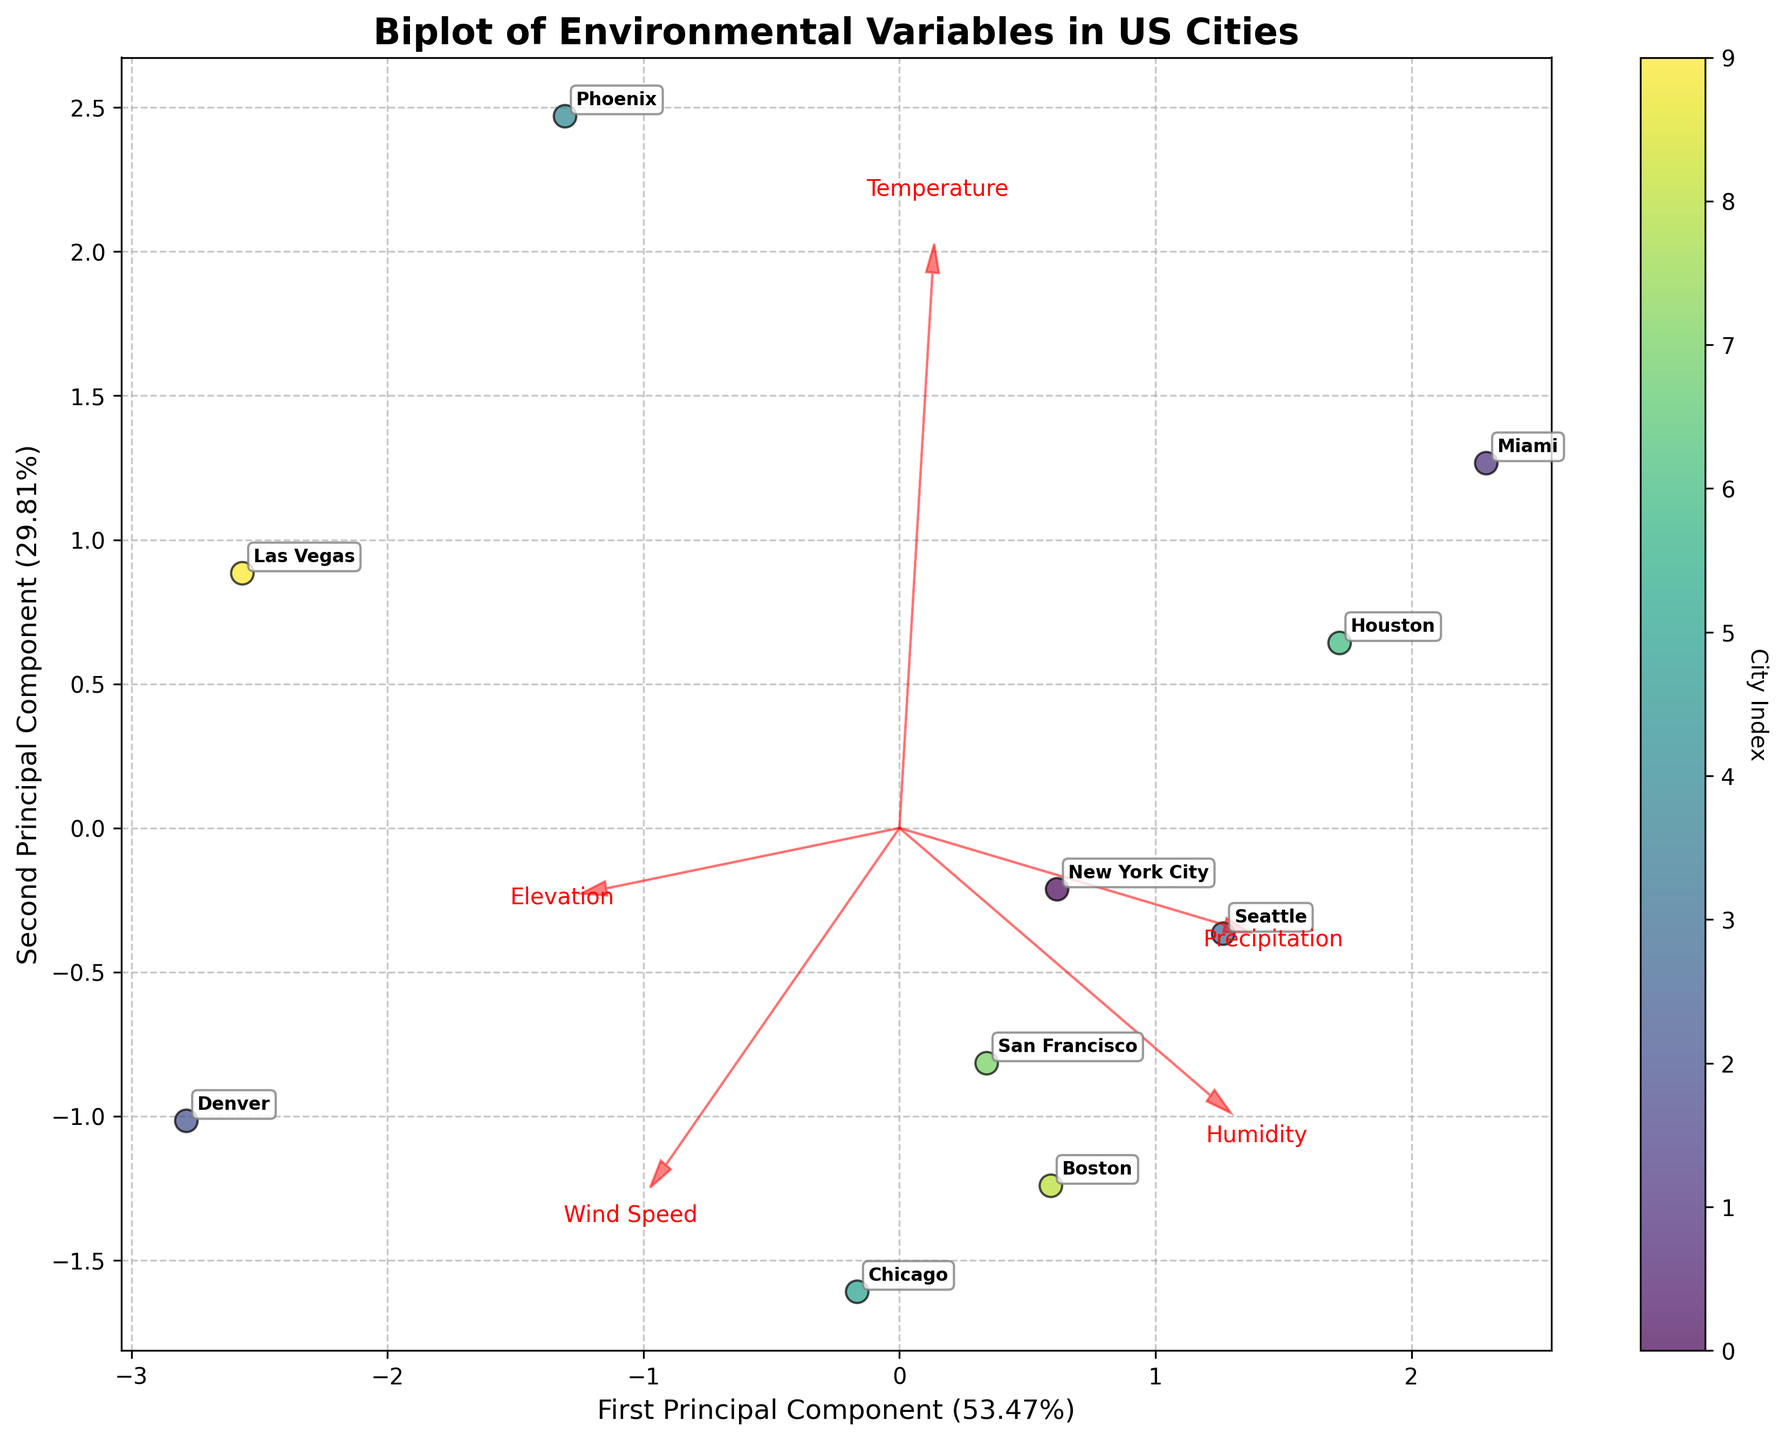What's the title of the plot? The title is typically displayed at the top of the plot. From the instructions, it is mentioned that the plot title is "Biplot of Environmental Variables in US Cities".
Answer: Biplot of Environmental Variables in US Cities What are the names of the five environmental variables represented by the feature vectors? The feature vectors in red represent the environmental variables. The names of these variables were mentioned to be labeled along the arrows in the code provided: Temperature, Precipitation, Humidity, Wind Speed, and Elevation.
Answer: Temperature, Precipitation, Humidity, Wind Speed, Elevation Which city is closest to the origin in the biplot? Identify the point that is closest to (0, 0) in the plot. According to the code, cities are labeled near their points. By looking at the annotated points, locate the city nearest to the origin.
Answer: Seattle Which environmental variable has the longest vector in the biplot? The length of the vector corresponds to the contribution of the variable in the principal components. The longest arrow points toward the variable representing the largest contribution. Visually identify this longest arrow in the plot.
Answer: Elevation How much variance do the first and second principal components explain together? The explanation mentions explicitly labeled axes with percentages of variance explained. Adding the percentages of the first and second principal components gives the total variance explained.
Answer: Roughly 100% Which two cities have the most similar environmental profiles based on their positions in the biplot? Identify the cities whose points are closest together in the 2D plot, indicating similar environmental profiles.
Answer: Boston and Chicago Which city shows the highest precipitation in relation to the principal components? Arrows indicate the influence of variables. The city positioned furthest along the direction of the Precipitation arrow indicates the highest precipitation. Identify the city that is most in line with this arrow.
Answer: Miami Which environmental variable is most strongly associated with the second principal component? Examine the vector directions and magnitudes. The variable most aligned with the vertical axis (second principal component) and with the highest magnitude is the one most strongly associated.
Answer: Humidity How does the Wind Speed variable relate to the geographical locations of the cities in the biplot? Compare the direction and length of the Wind Speed vector with the cities' points. Cities along this direction indicate higher wind speeds proportional to their distances in the plot.
Answer: Higher for cities like Chicago and Las Vegas Which two cities have the most divergent environmental profiles? Look for the two cities plotted furthest apart in any direction, indicating the greatest differences in their environmental variables.
Answer: Phoenix and Seattle 